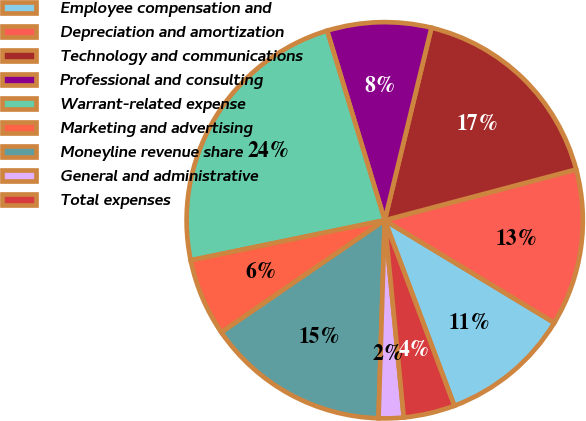Convert chart. <chart><loc_0><loc_0><loc_500><loc_500><pie_chart><fcel>Employee compensation and<fcel>Depreciation and amortization<fcel>Technology and communications<fcel>Professional and consulting<fcel>Warrant-related expense<fcel>Marketing and advertising<fcel>Moneyline revenue share<fcel>General and administrative<fcel>Total expenses<nl><fcel>10.63%<fcel>12.78%<fcel>17.08%<fcel>8.48%<fcel>23.54%<fcel>6.33%<fcel>14.93%<fcel>2.03%<fcel>4.18%<nl></chart> 